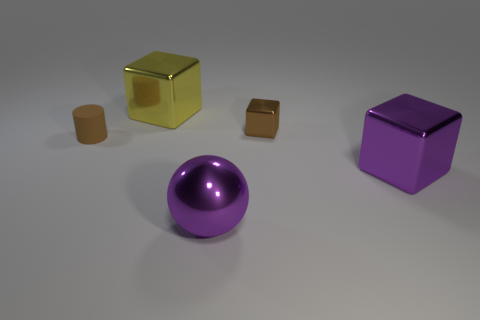Are there any small rubber objects behind the small brown block?
Your answer should be compact. No. What number of other objects are the same size as the yellow metal block?
Provide a succinct answer. 2. The large thing that is in front of the large yellow metallic object and to the left of the brown block is made of what material?
Your answer should be compact. Metal. Do the large metallic object that is behind the small brown shiny object and the brown thing that is right of the tiny brown rubber object have the same shape?
Keep it short and to the point. Yes. Is there any other thing that is the same material as the tiny cylinder?
Your answer should be very brief. No. The large metal thing behind the object that is on the right side of the tiny object on the right side of the yellow block is what shape?
Your answer should be compact. Cube. What number of other objects are there of the same shape as the yellow thing?
Your answer should be compact. 2. What color is the metal sphere that is the same size as the yellow metal block?
Your answer should be very brief. Purple. What number of spheres are either big blue things or tiny metallic things?
Offer a terse response. 0. How many small brown objects are there?
Your answer should be compact. 2. 